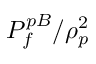Convert formula to latex. <formula><loc_0><loc_0><loc_500><loc_500>P _ { f } ^ { p B } / \rho _ { p } ^ { 2 }</formula> 